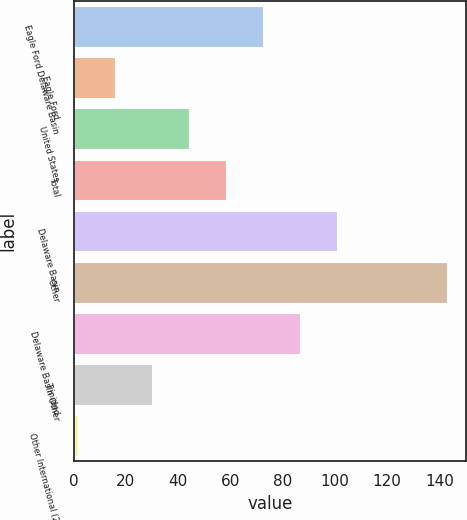Convert chart. <chart><loc_0><loc_0><loc_500><loc_500><bar_chart><fcel>Eagle Ford Delaware Basin<fcel>Eagle Ford<fcel>United States<fcel>Total<fcel>Delaware Basin<fcel>Other<fcel>Delaware Basin Other<fcel>Trinidad<fcel>Other International (2)<nl><fcel>72.4<fcel>15.92<fcel>44.16<fcel>58.28<fcel>100.64<fcel>143<fcel>86.52<fcel>30.04<fcel>1.8<nl></chart> 